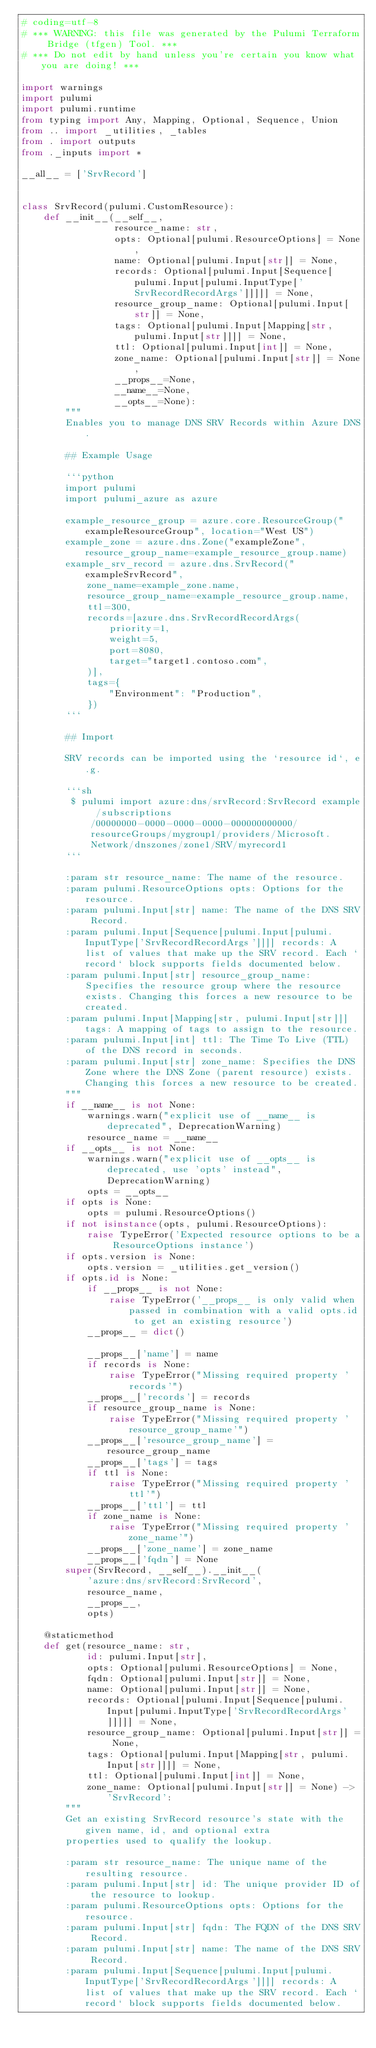<code> <loc_0><loc_0><loc_500><loc_500><_Python_># coding=utf-8
# *** WARNING: this file was generated by the Pulumi Terraform Bridge (tfgen) Tool. ***
# *** Do not edit by hand unless you're certain you know what you are doing! ***

import warnings
import pulumi
import pulumi.runtime
from typing import Any, Mapping, Optional, Sequence, Union
from .. import _utilities, _tables
from . import outputs
from ._inputs import *

__all__ = ['SrvRecord']


class SrvRecord(pulumi.CustomResource):
    def __init__(__self__,
                 resource_name: str,
                 opts: Optional[pulumi.ResourceOptions] = None,
                 name: Optional[pulumi.Input[str]] = None,
                 records: Optional[pulumi.Input[Sequence[pulumi.Input[pulumi.InputType['SrvRecordRecordArgs']]]]] = None,
                 resource_group_name: Optional[pulumi.Input[str]] = None,
                 tags: Optional[pulumi.Input[Mapping[str, pulumi.Input[str]]]] = None,
                 ttl: Optional[pulumi.Input[int]] = None,
                 zone_name: Optional[pulumi.Input[str]] = None,
                 __props__=None,
                 __name__=None,
                 __opts__=None):
        """
        Enables you to manage DNS SRV Records within Azure DNS.

        ## Example Usage

        ```python
        import pulumi
        import pulumi_azure as azure

        example_resource_group = azure.core.ResourceGroup("exampleResourceGroup", location="West US")
        example_zone = azure.dns.Zone("exampleZone", resource_group_name=example_resource_group.name)
        example_srv_record = azure.dns.SrvRecord("exampleSrvRecord",
            zone_name=example_zone.name,
            resource_group_name=example_resource_group.name,
            ttl=300,
            records=[azure.dns.SrvRecordRecordArgs(
                priority=1,
                weight=5,
                port=8080,
                target="target1.contoso.com",
            )],
            tags={
                "Environment": "Production",
            })
        ```

        ## Import

        SRV records can be imported using the `resource id`, e.g.

        ```sh
         $ pulumi import azure:dns/srvRecord:SrvRecord example /subscriptions/00000000-0000-0000-0000-000000000000/resourceGroups/mygroup1/providers/Microsoft.Network/dnszones/zone1/SRV/myrecord1
        ```

        :param str resource_name: The name of the resource.
        :param pulumi.ResourceOptions opts: Options for the resource.
        :param pulumi.Input[str] name: The name of the DNS SRV Record.
        :param pulumi.Input[Sequence[pulumi.Input[pulumi.InputType['SrvRecordRecordArgs']]]] records: A list of values that make up the SRV record. Each `record` block supports fields documented below.
        :param pulumi.Input[str] resource_group_name: Specifies the resource group where the resource exists. Changing this forces a new resource to be created.
        :param pulumi.Input[Mapping[str, pulumi.Input[str]]] tags: A mapping of tags to assign to the resource.
        :param pulumi.Input[int] ttl: The Time To Live (TTL) of the DNS record in seconds.
        :param pulumi.Input[str] zone_name: Specifies the DNS Zone where the DNS Zone (parent resource) exists. Changing this forces a new resource to be created.
        """
        if __name__ is not None:
            warnings.warn("explicit use of __name__ is deprecated", DeprecationWarning)
            resource_name = __name__
        if __opts__ is not None:
            warnings.warn("explicit use of __opts__ is deprecated, use 'opts' instead", DeprecationWarning)
            opts = __opts__
        if opts is None:
            opts = pulumi.ResourceOptions()
        if not isinstance(opts, pulumi.ResourceOptions):
            raise TypeError('Expected resource options to be a ResourceOptions instance')
        if opts.version is None:
            opts.version = _utilities.get_version()
        if opts.id is None:
            if __props__ is not None:
                raise TypeError('__props__ is only valid when passed in combination with a valid opts.id to get an existing resource')
            __props__ = dict()

            __props__['name'] = name
            if records is None:
                raise TypeError("Missing required property 'records'")
            __props__['records'] = records
            if resource_group_name is None:
                raise TypeError("Missing required property 'resource_group_name'")
            __props__['resource_group_name'] = resource_group_name
            __props__['tags'] = tags
            if ttl is None:
                raise TypeError("Missing required property 'ttl'")
            __props__['ttl'] = ttl
            if zone_name is None:
                raise TypeError("Missing required property 'zone_name'")
            __props__['zone_name'] = zone_name
            __props__['fqdn'] = None
        super(SrvRecord, __self__).__init__(
            'azure:dns/srvRecord:SrvRecord',
            resource_name,
            __props__,
            opts)

    @staticmethod
    def get(resource_name: str,
            id: pulumi.Input[str],
            opts: Optional[pulumi.ResourceOptions] = None,
            fqdn: Optional[pulumi.Input[str]] = None,
            name: Optional[pulumi.Input[str]] = None,
            records: Optional[pulumi.Input[Sequence[pulumi.Input[pulumi.InputType['SrvRecordRecordArgs']]]]] = None,
            resource_group_name: Optional[pulumi.Input[str]] = None,
            tags: Optional[pulumi.Input[Mapping[str, pulumi.Input[str]]]] = None,
            ttl: Optional[pulumi.Input[int]] = None,
            zone_name: Optional[pulumi.Input[str]] = None) -> 'SrvRecord':
        """
        Get an existing SrvRecord resource's state with the given name, id, and optional extra
        properties used to qualify the lookup.

        :param str resource_name: The unique name of the resulting resource.
        :param pulumi.Input[str] id: The unique provider ID of the resource to lookup.
        :param pulumi.ResourceOptions opts: Options for the resource.
        :param pulumi.Input[str] fqdn: The FQDN of the DNS SRV Record.
        :param pulumi.Input[str] name: The name of the DNS SRV Record.
        :param pulumi.Input[Sequence[pulumi.Input[pulumi.InputType['SrvRecordRecordArgs']]]] records: A list of values that make up the SRV record. Each `record` block supports fields documented below.</code> 